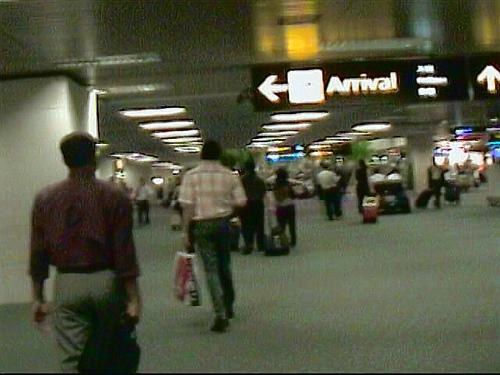What is in the suitcase?
Give a very brief answer. Clothes. What's closest to the lens?
Short answer required. Man. What type of building is this picture taken in?
Keep it brief. Airport. What color is the lighted sign?
Keep it brief. White. Is this a public place?
Keep it brief. Yes. What direction is arrival flights?
Write a very short answer. Left. Is this indoors?
Short answer required. Yes. Could there be a flight delay?
Answer briefly. Yes. Are there any red suitcases?
Write a very short answer. No. What color is the light?
Short answer required. White. 